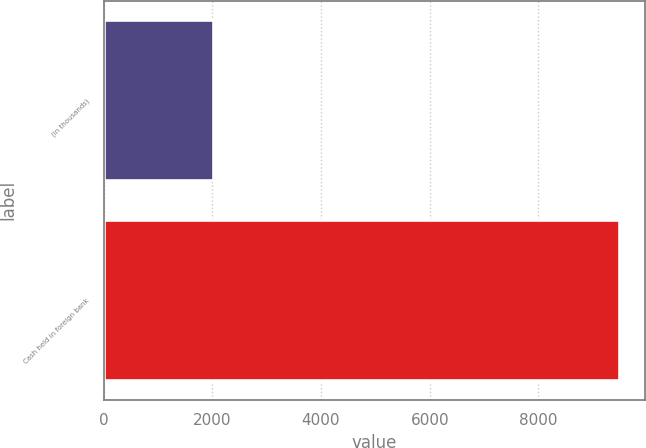Convert chart. <chart><loc_0><loc_0><loc_500><loc_500><bar_chart><fcel>(in thousands)<fcel>Cash held in foreign bank<nl><fcel>2006<fcel>9487<nl></chart> 